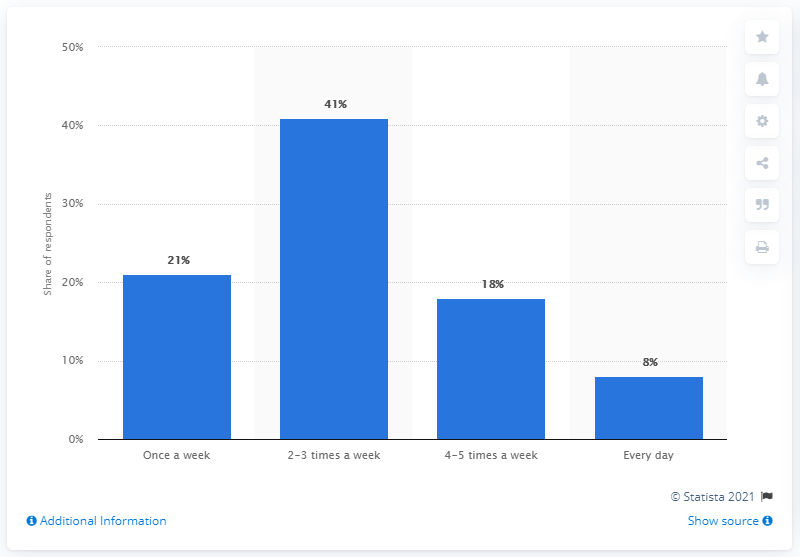Indicate a few pertinent items in this graphic. According to the survey results in Poland, 8% of respondents reported having sex every day. 